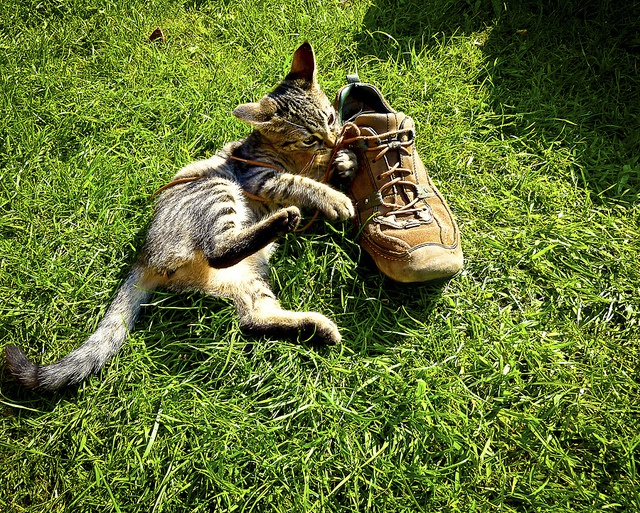Describe the objects in this image and their specific colors. I can see a cat in darkgreen, black, ivory, gray, and olive tones in this image. 